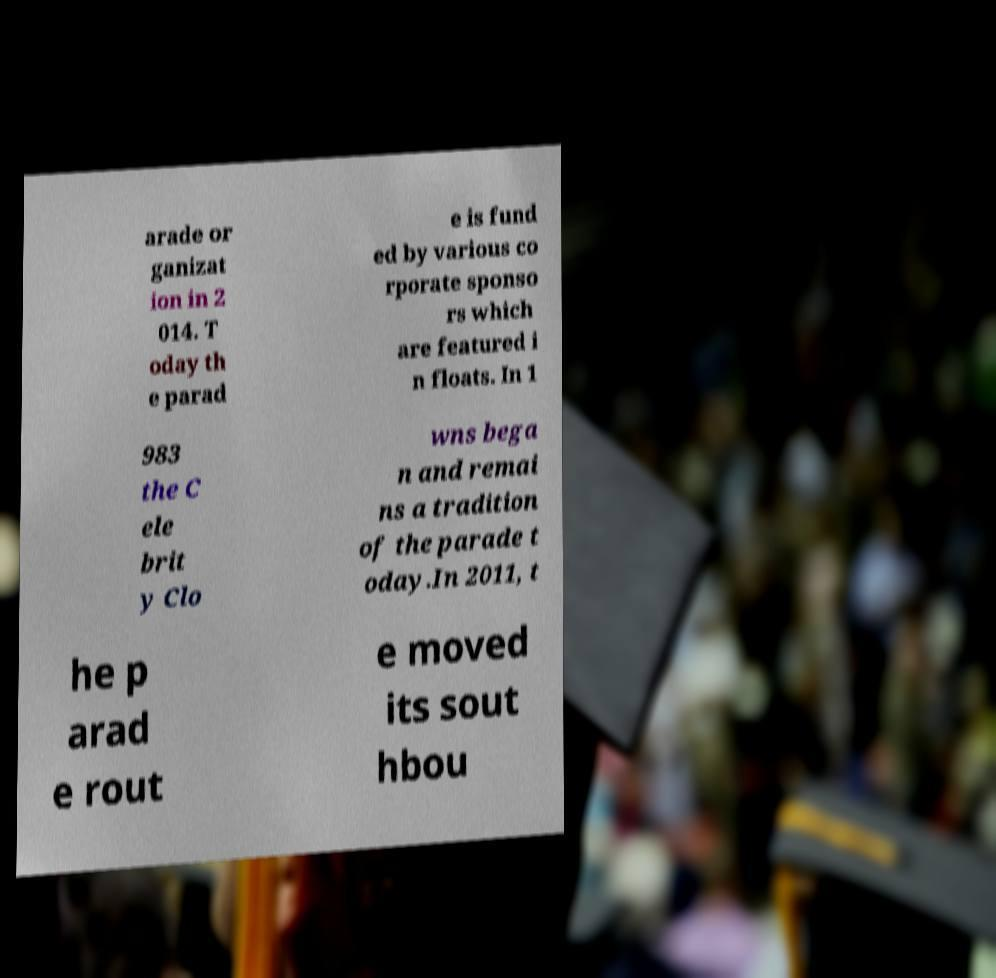Can you read and provide the text displayed in the image?This photo seems to have some interesting text. Can you extract and type it out for me? arade or ganizat ion in 2 014. T oday th e parad e is fund ed by various co rporate sponso rs which are featured i n floats. In 1 983 the C ele brit y Clo wns bega n and remai ns a tradition of the parade t oday.In 2011, t he p arad e rout e moved its sout hbou 